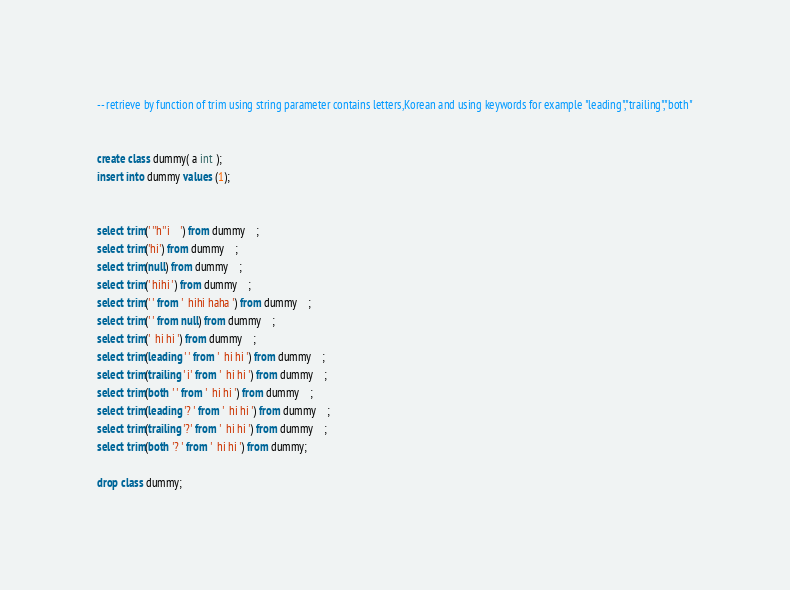<code> <loc_0><loc_0><loc_500><loc_500><_SQL_>-- retrieve by function of trim using string parameter contains letters,Korean and using keywords for example "leading","trailing","both"


create class dummy( a int );
insert into dummy values (1);


select trim(' ''h''i    ') from dummy	;
select trim('hi') from dummy	;
select trim(null) from dummy	;
select trim(' hihi ') from dummy	;
select trim(' ' from '  hihi haha ') from dummy	;
select trim(' ' from null) from dummy	;
select trim('  hi hi ') from dummy	;
select trim(leading ' ' from '  hi hi ') from dummy	;
select trim(trailing ' i' from '  hi hi ') from dummy	;
select trim(both ' ' from '  hi hi ') from dummy	;
select trim(leading '? ' from '  hi hi ') from dummy	;
select trim(trailing '?' from '  hi hi ') from dummy	;
select trim(both '? ' from '  hi hi ') from dummy;

drop class dummy;</code> 